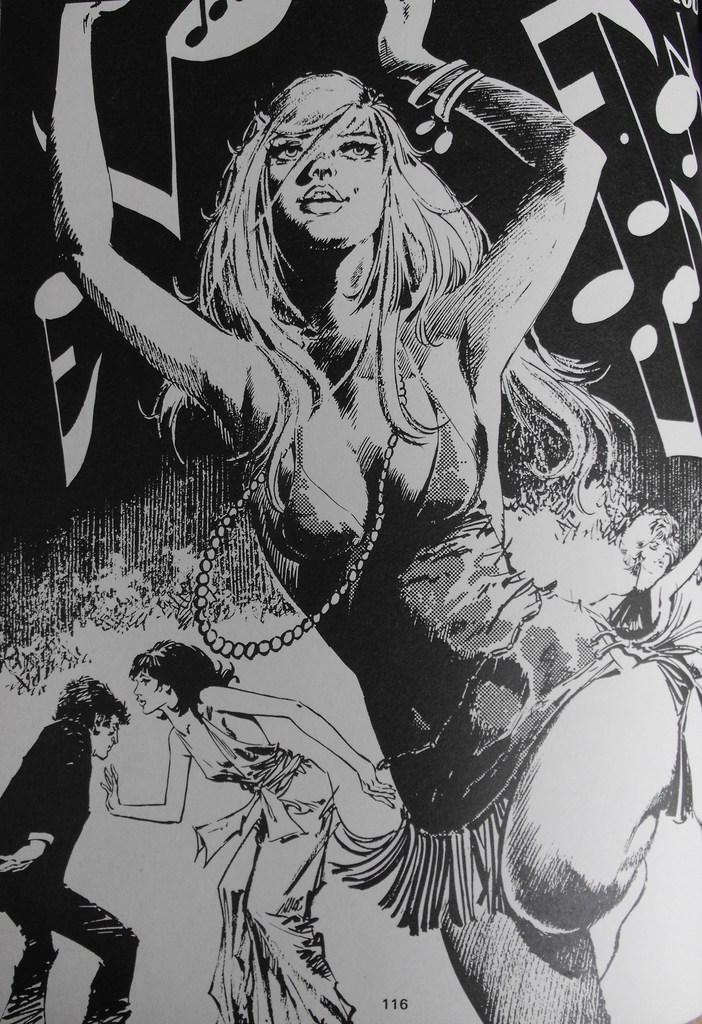What is the main subject of the image? There is a painting in the image. What is happening in the painting? The painting depicts people dancing. What other elements are present in the painting? There are musical notes on the painting. What color is the scarf worn by the person in the painting? There is no scarf present in the painting; it depicts people dancing with musical notes. 